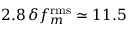<formula> <loc_0><loc_0><loc_500><loc_500>2 . 8 \, \delta f _ { m } ^ { r m s } \simeq 1 1 . 5</formula> 